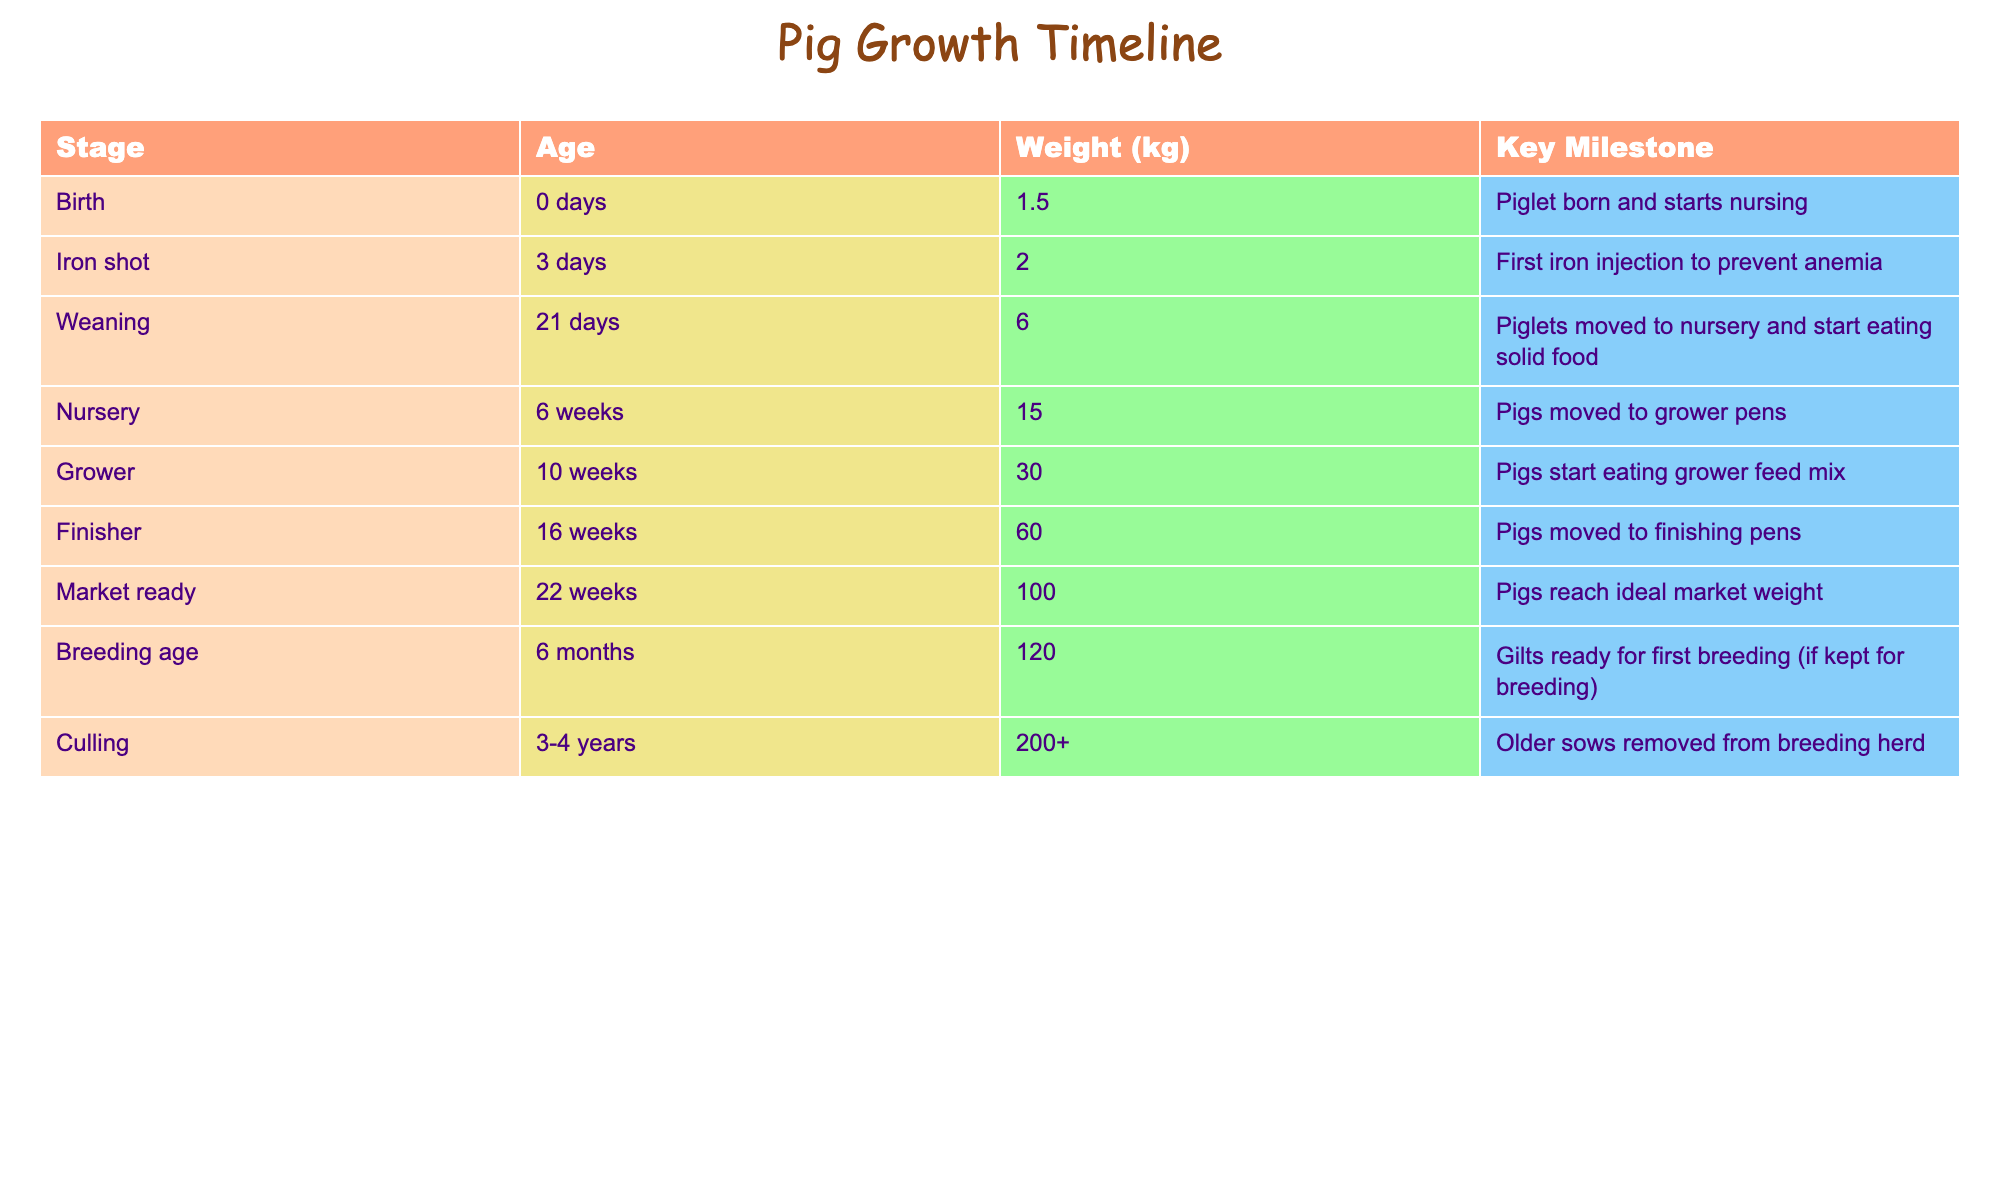What is the weight of a pig at the Weaning stage? The weight of a pig at the Weaning stage is listed in the table, where it shows that at 21 days, the weight is 6 kg.
Answer: 6 kg At what age do pigs start eating solid food? The table indicates that pigs are moved to the nursery and start eating solid food at the Weaning stage, which is at 21 days.
Answer: 21 days Is it true that pigs reach market weight at 22 weeks? The table states that pigs reach ideal market weight at 22 weeks, confirming that this statement is true.
Answer: Yes What is the average weight of pigs from Weaning to Market ready? The weights at these stages are 6 kg (Weaning), 30 kg (Grower), and 100 kg (Market ready). To find the average, we add these weights (6 + 30 + 100 = 136) and divide by 3, which equals approximately 45.33 kg.
Answer: 45.33 kg At which stage are pigs first given an iron injection? Referring to the table, the first iron injection is given 3 days after birth, during the Iron shot stage.
Answer: 3 days How much weight do pigs gain from the Nursery stage to the Finisher stage? The weight at the Nursery stage is 15 kg and at the Finisher stage is 60 kg. The weight gain can be calculated by subtracting the Nursery weight from the Finisher weight: 60 - 15 = 45 kg.
Answer: 45 kg At what age are gilts ready for first breeding? The table shows that gilts are ready for first breeding at 6 months of age.
Answer: 6 months If a pig is 3 years old, what is its likely weight? According to the table, older sows removed from the breeding herd are about 200 kg or more, indicating that a 3-year-old pig is likely to weigh at least this much.
Answer: 200 kg or more 